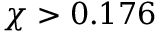Convert formula to latex. <formula><loc_0><loc_0><loc_500><loc_500>\chi > 0 . 1 7 6</formula> 